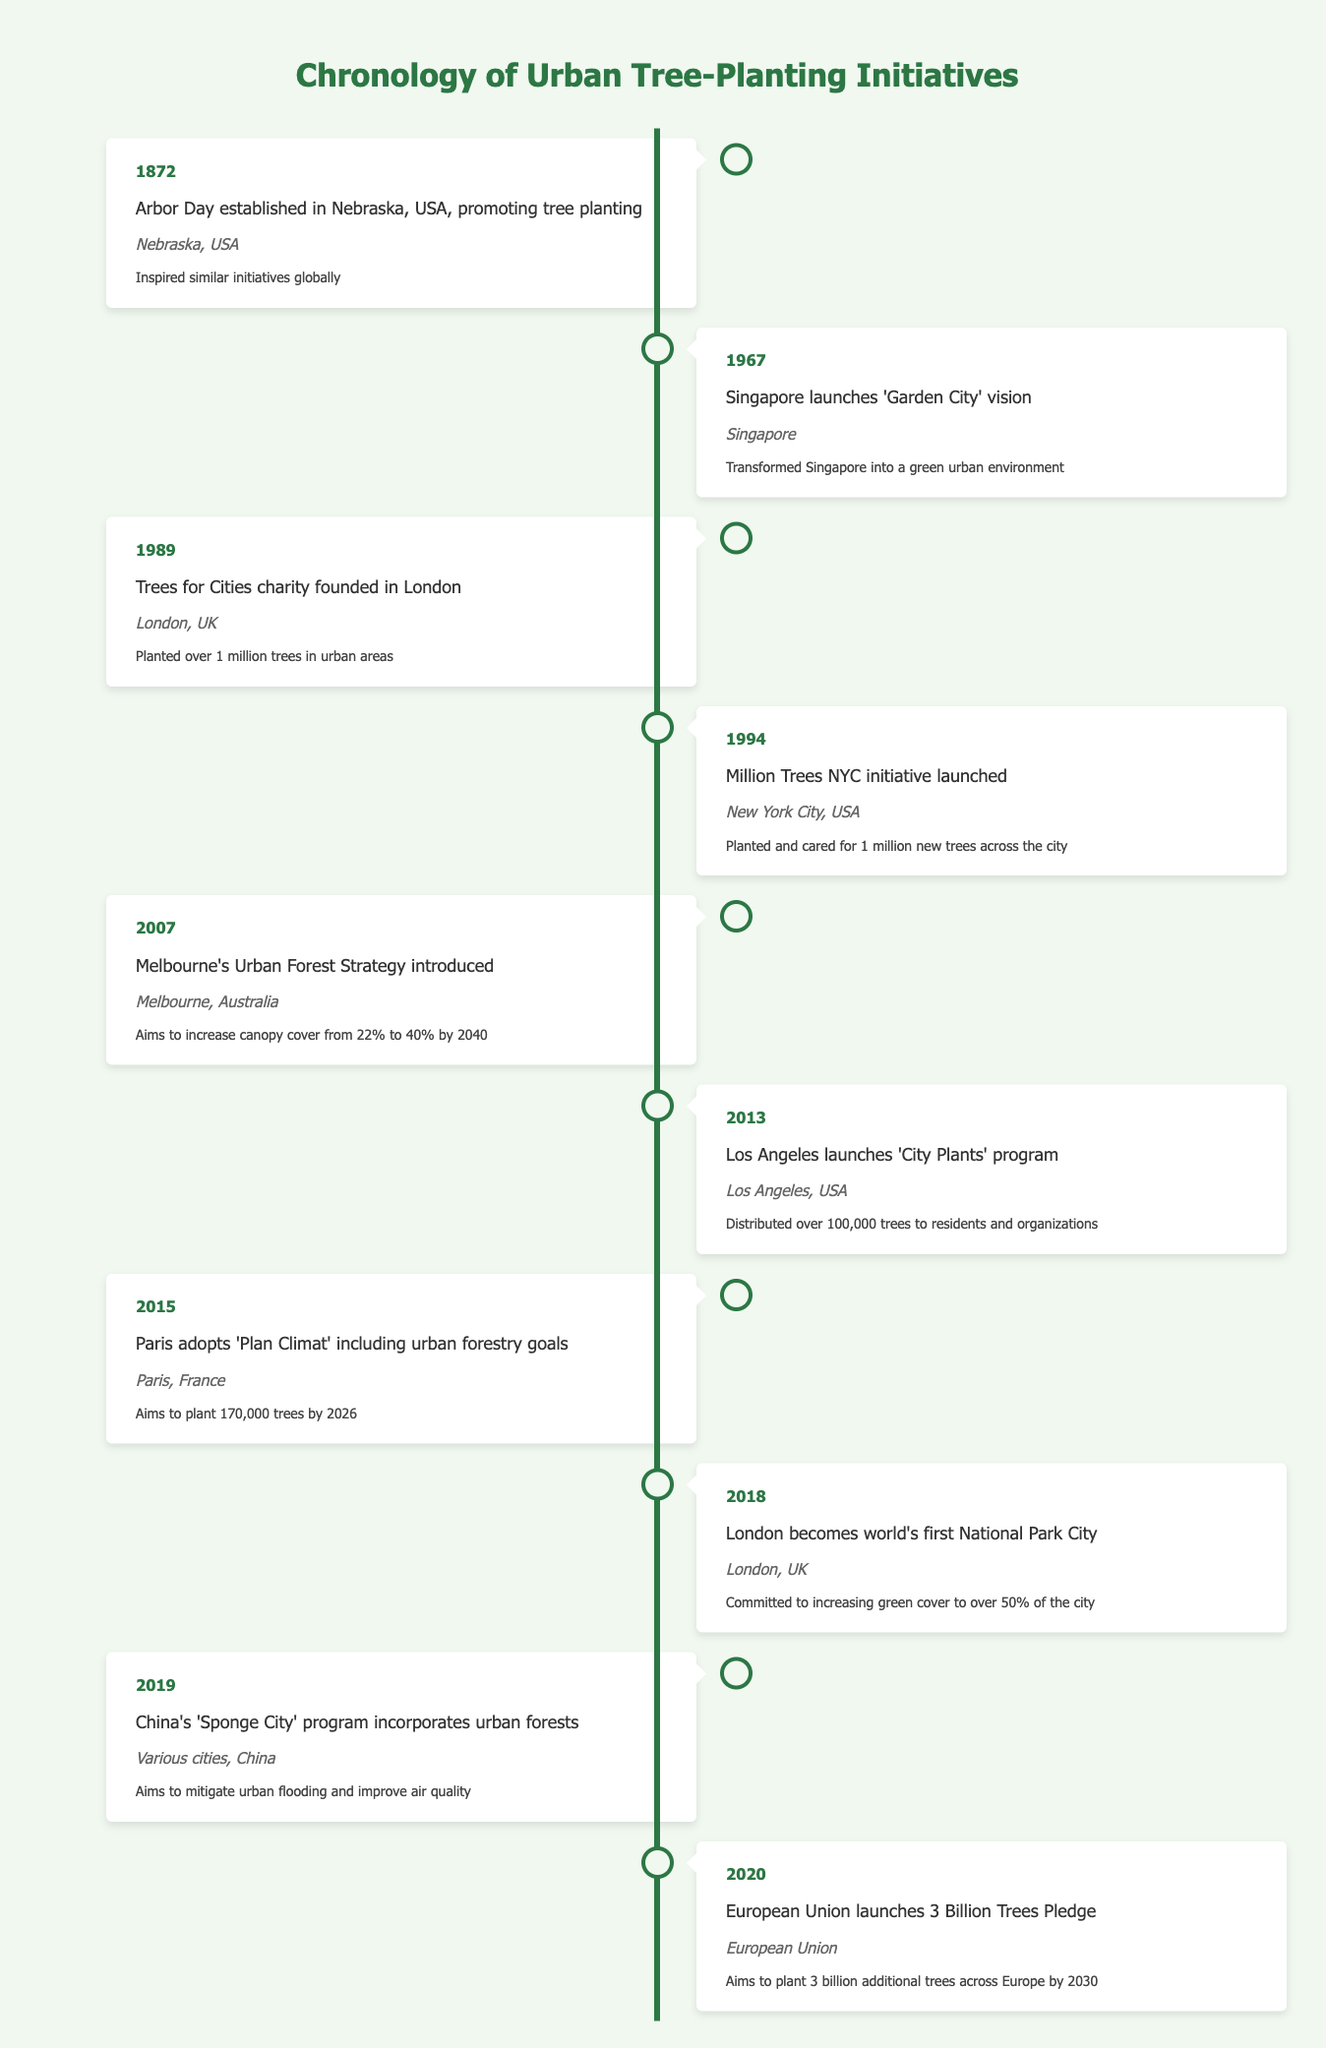What year was Arbor Day established? According to the table, Arbor Day was established in 1872 in Nebraska, USA.
Answer: 1872 Which city launched the 'Garden City' vision in 1967? The table indicates that Singapore launched the 'Garden City' vision in 1967.
Answer: Singapore How many trees did the Trees for Cities charity plant in London? The data states that the Trees for Cities charity planted over 1 million trees in urban areas.
Answer: Over 1 million Did Los Angeles distribute more or fewer than 100,000 trees through the 'City Plants' program? The table confirms that Los Angeles distributed over 100,000 trees to residents and organizations through the program.
Answer: More than 100,000 What is the difference between the tree-planting goals of Paris and the Million Trees NYC initiative? Paris aims to plant 170,000 trees by 2026 while Million Trees NYC aimed to plant and care for 1 million trees, so the difference in goals depends on the time frame but the Paris goal is less numerically.
Answer: 829,000 Which initiative aims to increase urban forestry canopy cover to 40% by 2040? The Melbourne Urban Forest Strategy introduced in 2007 specifically aims to increase the canopy cover from 22% to 40% by 2040.
Answer: Melbourne's Urban Forest Strategy In what year did the Chinese 'Sponge City' program incorporate urban forests? According to the table, the 'Sponge City' program incorporated urban forests in 2019.
Answer: 2019 Is it true that the European Union's tree-planting pledge covers a time frame until 2030? The table verifies that the European Union's 3 Billion Trees Pledge aims to plant additional trees across Europe by 2030, making it true.
Answer: True What are the total initiatives mentioned in the timeline aimed at improving urban environments? The table lists 10 different initiatives aimed at improving urban environments through tree planting, starting from Arbor Day in 1872 to the EU pledge in 2020.
Answer: 10 initiatives 